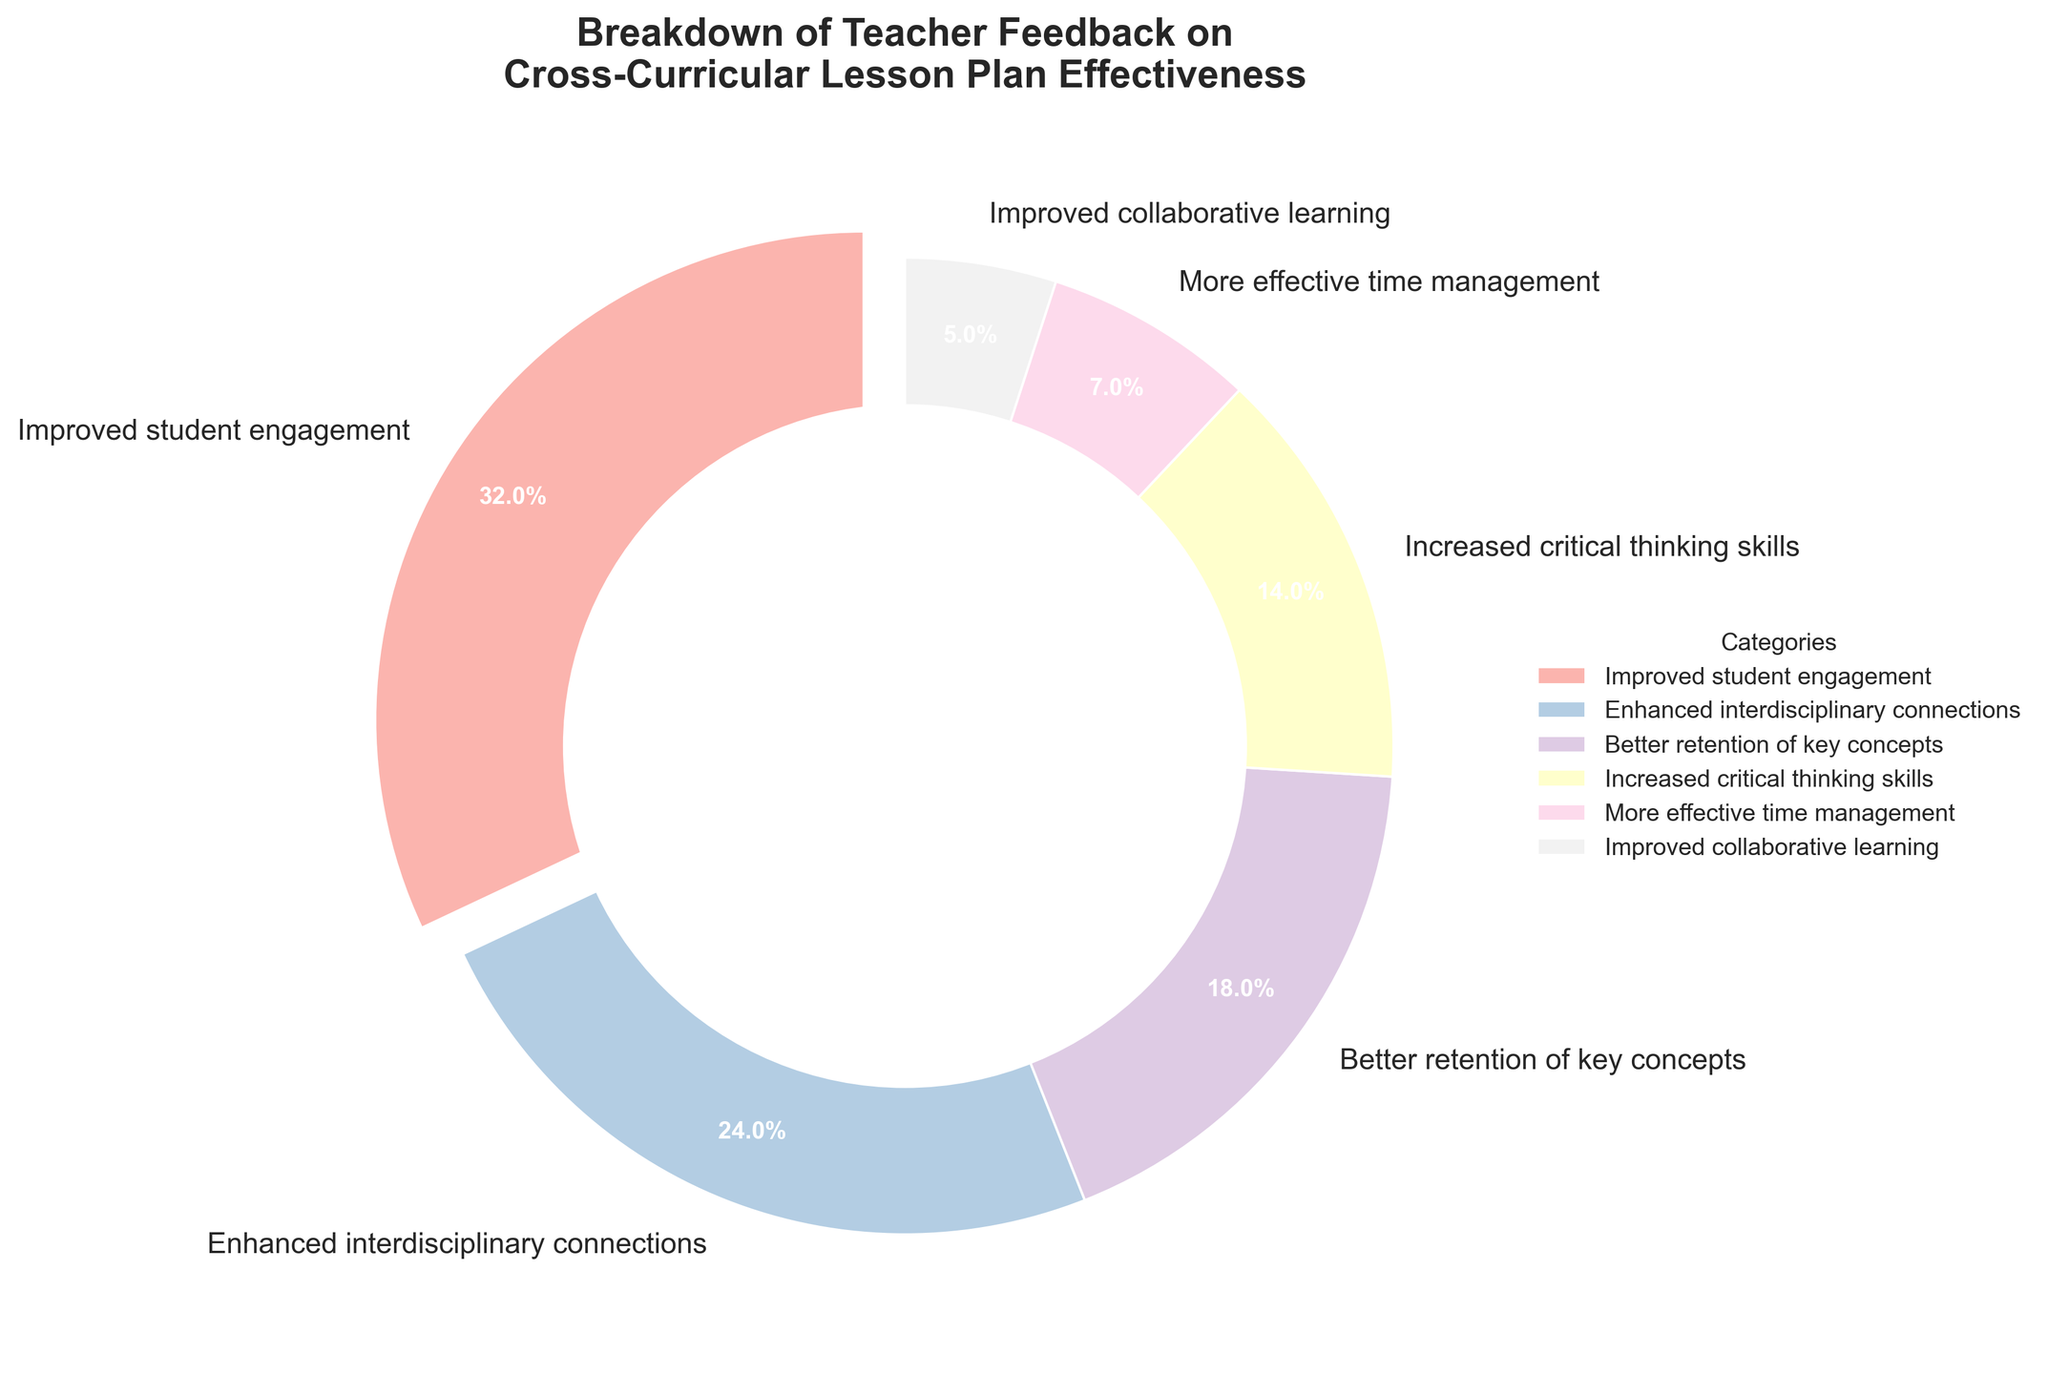What percentage of teacher feedback indicated improved student engagement? The slice labeled "Improved student engagement" shows 32%.
Answer: 32% Which category received the lowest percentage of teacher feedback? The category "Improved collaborative learning" has the smallest slice at 5%.
Answer: Improved collaborative learning How much larger is the percentage of feedback for "Improved student engagement" compared to "More effective time management"? "Improved student engagement" has 32%, and "More effective time management" has 7%. The difference is 32% - 7% = 25%.
Answer: 25% Which feedback categories together constitute more than half of the total feedback? Adding the percentages of the top categories: "Improved student engagement" (32%), "Enhanced interdisciplinary connections" (24%), and "Better retention of key concepts" (18%) gives 32% + 24% + 18% = 74%, which is more than half.
Answer: Improved student engagement, Enhanced interdisciplinary connections, Better retention of key concepts What is the combined percentage of feedback for "Increased critical thinking skills" and "More effective time management"? The percentages for "Increased critical thinking skills" and "More effective time management" are 14% and 7%, respectively. Adding them, 14% + 7% = 21%.
Answer: 21% Which category is represented by the slice with the second largest percentage? The second largest slice corresponds to "Enhanced interdisciplinary connections" at 24%.
Answer: Enhanced interdisciplinary connections How does the pie chart visually distinguish the category with the highest percentage of feedback? The slice for "Improved student engagement" is separated slightly (exploded) from the rest of the pie chart to highlight it.
Answer: It is separated (exploded) Are there more feedback categories below or above 20%? Categories above 20% are "Improved student engagement" (32%) and "Enhanced interdisciplinary connections" (24%). Categories below 20% are "Better retention of key concepts" (18%), "Increased critical thinking skills" (14%), "More effective time management" (7%), and "Improved collaborative learning" (5%). There are more categories below 20% (4) than above (2).
Answer: Below 20% Which feedback category closely follows "Better retention of key concepts" in percentage? "Increased critical thinking skills" follows "Better retention of key concepts" with a percentage of 14%, just below 18%.
Answer: Increased critical thinking skills 